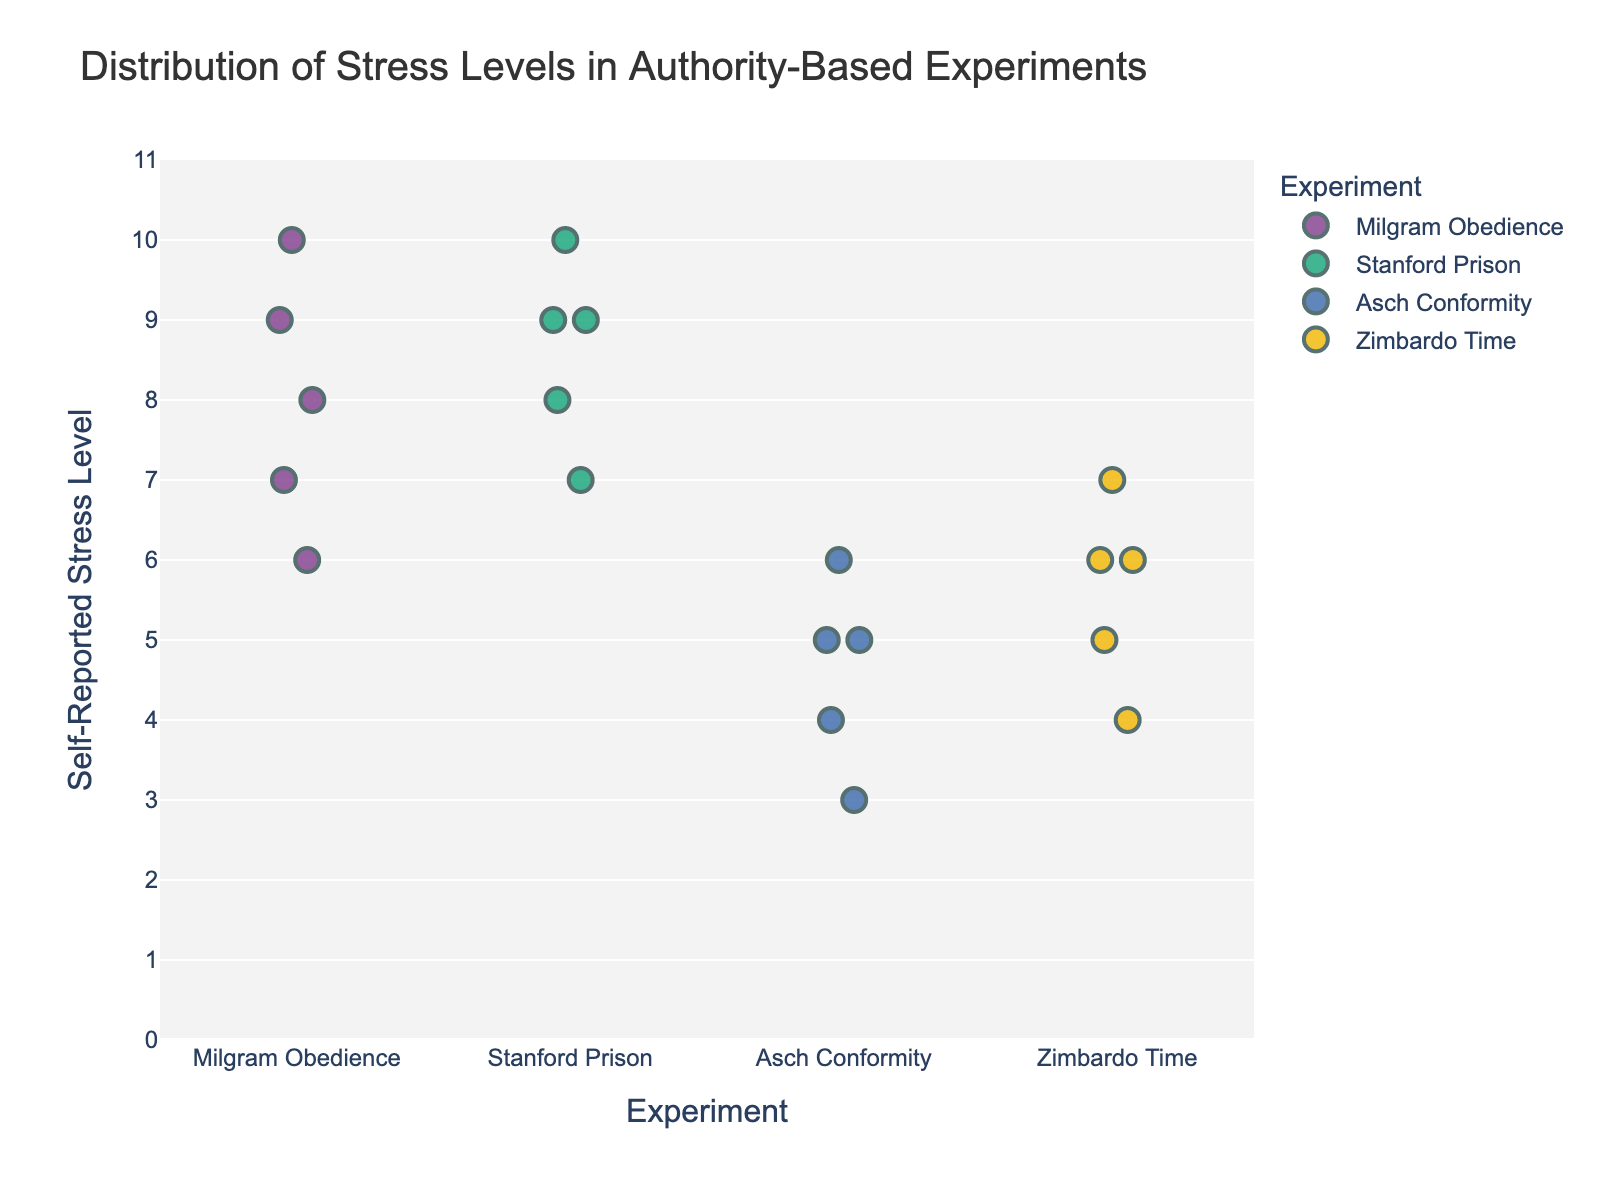What's the title of the figure? The title is displayed at the top of the figure, usually in a larger font to draw attention.
Answer: Distribution of Stress Levels in Authority-Based Experiments How many experiments are represented in the plot? Count the distinct labels on the x-axis that represent different experiments.
Answer: 4 Which experiment has the highest individual stress level reported? The highest stress level is marked on the y-axis and cross-referenced with the experiment's label on the x-axis.
Answer: Milgram Obedience and Stanford Prison What's the range of self-reported stress levels for the Asch Conformity experiment? Identify the highest and lowest stress levels represented by the scatter points within the Asch Conformity category on the x-axis.
Answer: 3 to 6 Which experiment has the most diverse range of stress levels? Compare the spread of data points along the y-axis for each experiment to see the range of values.
Answer: Milgram Obedience On average, how do stress levels compare between the Stanford Prison and Milgram Obedience experiments? Average the stress levels for both experiments and compare them. Steps: (1) Calculate the average for Stanford Prison (9+8+10+7+9)/5 = 8.6, (2) Calculate the average for Milgram Obedience (8+7+9+6+10)/5 = 8.
Answer: Similar, both are high Which experiment generally reported lower stress levels compared to others? Identify the experiment with data points that cluster lower on the y-axis relative to other experiments.
Answer: Asch Conformity Are there more reported stress levels above 7 or below 7 for the Zimbardo Time experiment? Count data points for Zimbardo Time above 7 and below 7 on the y-axis.
Answer: Below 7 What is the interquartile range (IQR) of stress levels for the Milgram Obedience experiment? Determine the values at the 25th percentile (Q1) and 75th percentile (Q3) for Milgram Obedience, then subtract Q1 from Q3. Data: 6, 7, 8, 9, 10. Q1=7, Q3=9. IQR: 9-7
Answer: 2 Which experiment has the tightest clustering of stress levels? Observe which experiment has data points that are closely packed together on the y-axis.
Answer: Zimbardo Time 